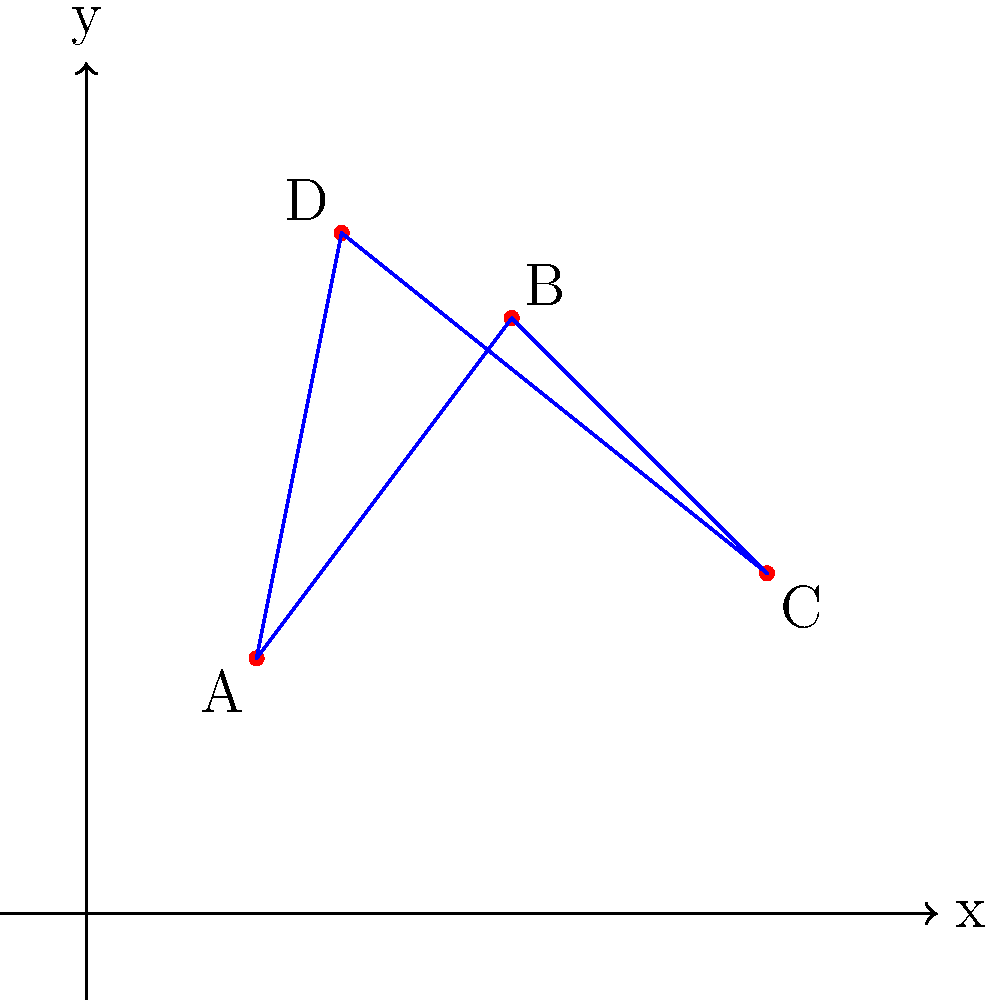Recall a memorable moment from high school with Bibijana Čujec. On the given coordinate plane, four points (A, B, C, and D) form a quadrilateral shape. If this shape represents the table arrangement during a group project you worked on together, what is the area of the quadrilateral in square units? To find the area of the quadrilateral, we can use the shoelace formula (also known as the surveyor's formula). This method calculates the area of a polygon given the coordinates of its vertices.

Step 1: Identify the coordinates of the points:
A(2,3), B(5,7), C(8,4), D(3,8)

Step 2: Apply the shoelace formula:
Area = $\frac{1}{2}|((x_1y_2 + x_2y_3 + x_3y_4 + x_4y_1) - (y_1x_2 + y_2x_3 + y_3x_4 + y_4x_1))|$

Step 3: Substitute the values:
Area = $\frac{1}{2}|((2 \cdot 7 + 5 \cdot 4 + 8 \cdot 8 + 3 \cdot 3) - (3 \cdot 5 + 7 \cdot 8 + 4 \cdot 3 + 8 \cdot 2))|$

Step 4: Calculate:
Area = $\frac{1}{2}|((14 + 20 + 64 + 9) - (15 + 56 + 12 + 16))|$
Area = $\frac{1}{2}|(107 - 99)|$
Area = $\frac{1}{2}(8)$
Area = 4

Therefore, the area of the quadrilateral is 4 square units.
Answer: 4 square units 